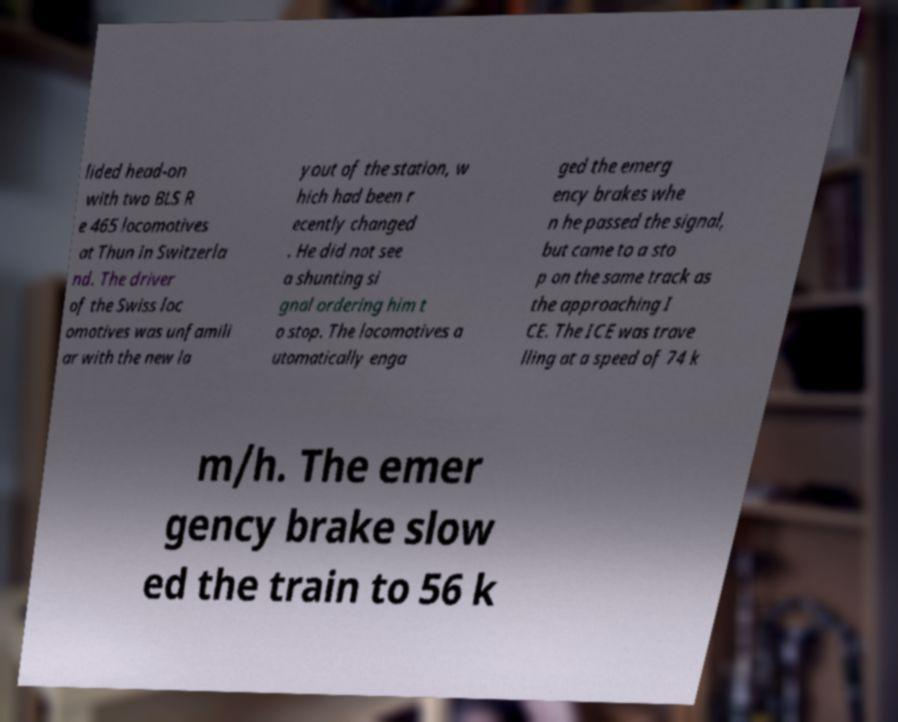What messages or text are displayed in this image? I need them in a readable, typed format. lided head-on with two BLS R e 465 locomotives at Thun in Switzerla nd. The driver of the Swiss loc omotives was unfamili ar with the new la yout of the station, w hich had been r ecently changed . He did not see a shunting si gnal ordering him t o stop. The locomotives a utomatically enga ged the emerg ency brakes whe n he passed the signal, but came to a sto p on the same track as the approaching I CE. The ICE was trave lling at a speed of 74 k m/h. The emer gency brake slow ed the train to 56 k 